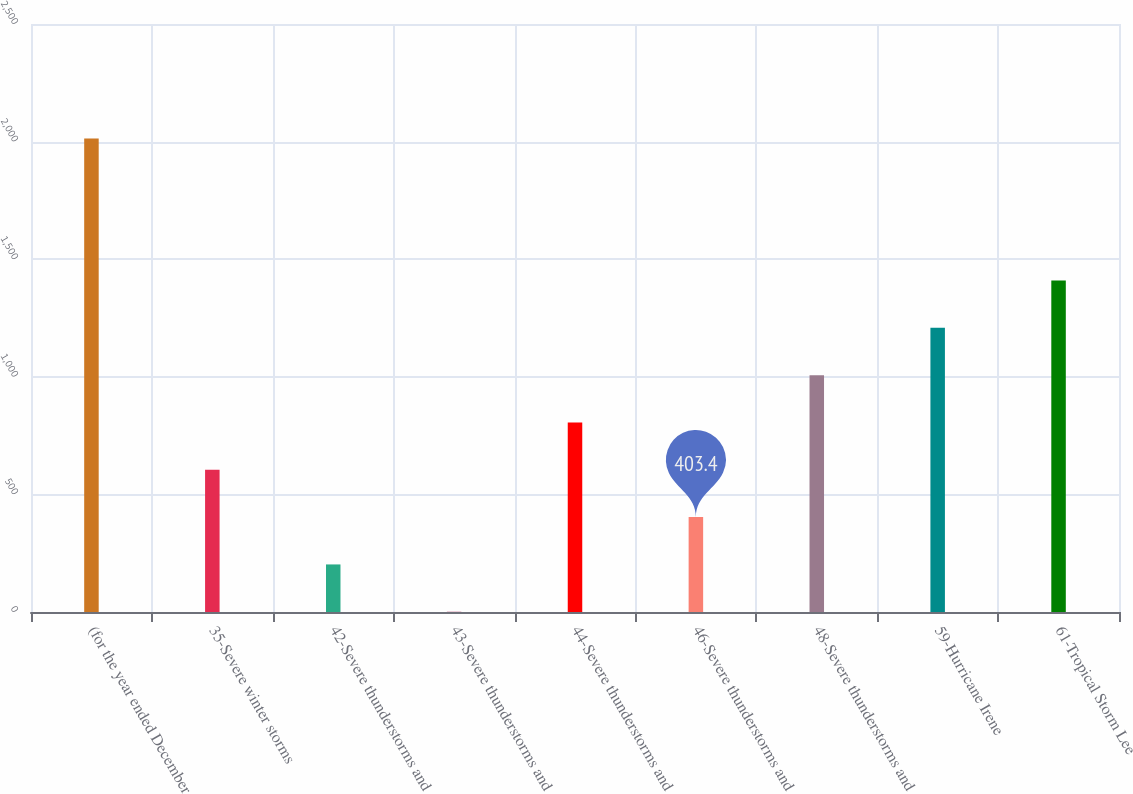Convert chart. <chart><loc_0><loc_0><loc_500><loc_500><bar_chart><fcel>(for the year ended December<fcel>35-Severe winter storms<fcel>42-Severe thunderstorms and<fcel>43-Severe thunderstorms and<fcel>44-Severe thunderstorms and<fcel>46-Severe thunderstorms and<fcel>48-Severe thunderstorms and<fcel>59-Hurricane Irene<fcel>61-Tropical Storm Lee<nl><fcel>2013<fcel>604.6<fcel>202.2<fcel>1<fcel>805.8<fcel>403.4<fcel>1007<fcel>1208.2<fcel>1409.4<nl></chart> 